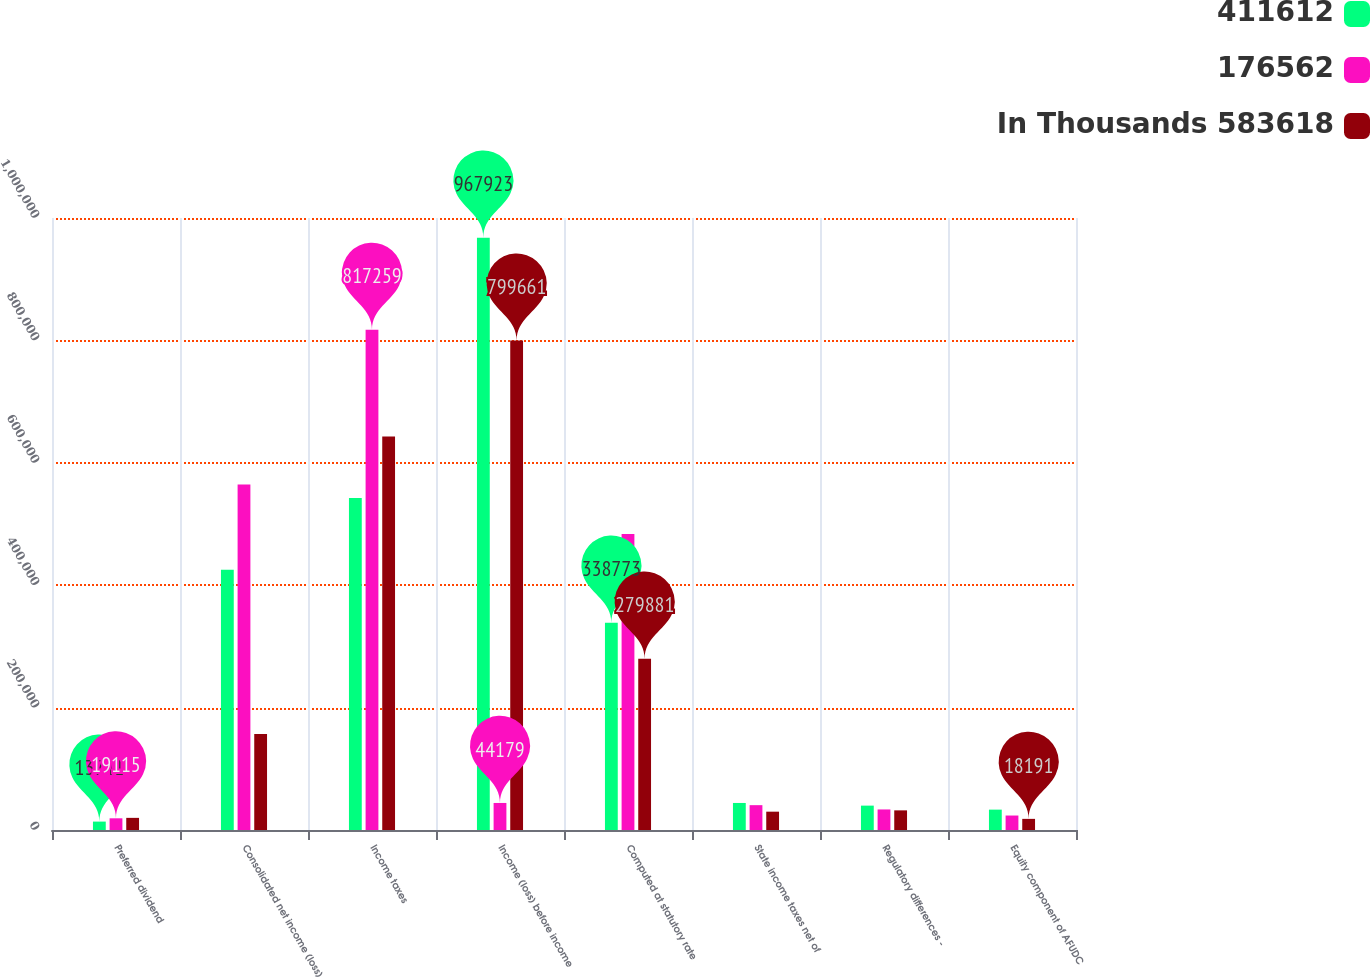Convert chart. <chart><loc_0><loc_0><loc_500><loc_500><stacked_bar_chart><ecel><fcel>Preferred dividend<fcel>Consolidated net income (loss)<fcel>Income taxes<fcel>Income (loss) before income<fcel>Computed at statutory rate<fcel>State income taxes net of<fcel>Regulatory differences -<fcel>Equity component of AFUDC<nl><fcel>411612<fcel>13741<fcel>425353<fcel>542570<fcel>967923<fcel>338773<fcel>44179<fcel>39825<fcel>33282<nl><fcel>176562<fcel>19115<fcel>564503<fcel>817259<fcel>44179<fcel>483617<fcel>40581<fcel>33581<fcel>23647<nl><fcel>In Thousands 583618<fcel>19828<fcel>156734<fcel>642927<fcel>799661<fcel>279881<fcel>29944<fcel>32089<fcel>18191<nl></chart> 